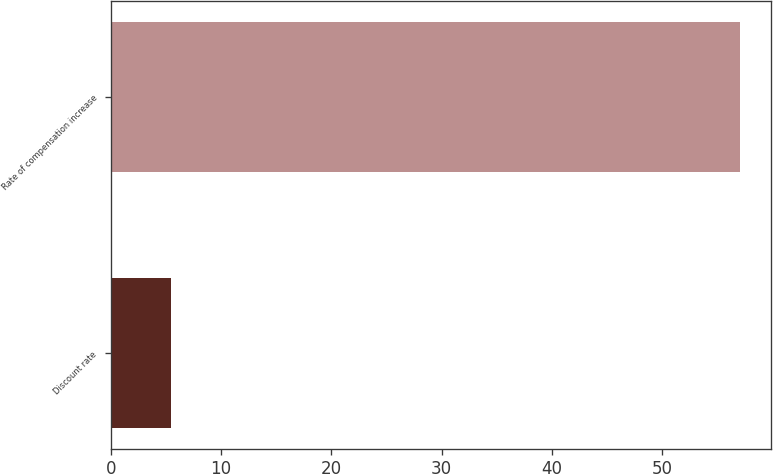Convert chart. <chart><loc_0><loc_0><loc_500><loc_500><bar_chart><fcel>Discount rate<fcel>Rate of compensation increase<nl><fcel>5.5<fcel>57<nl></chart> 